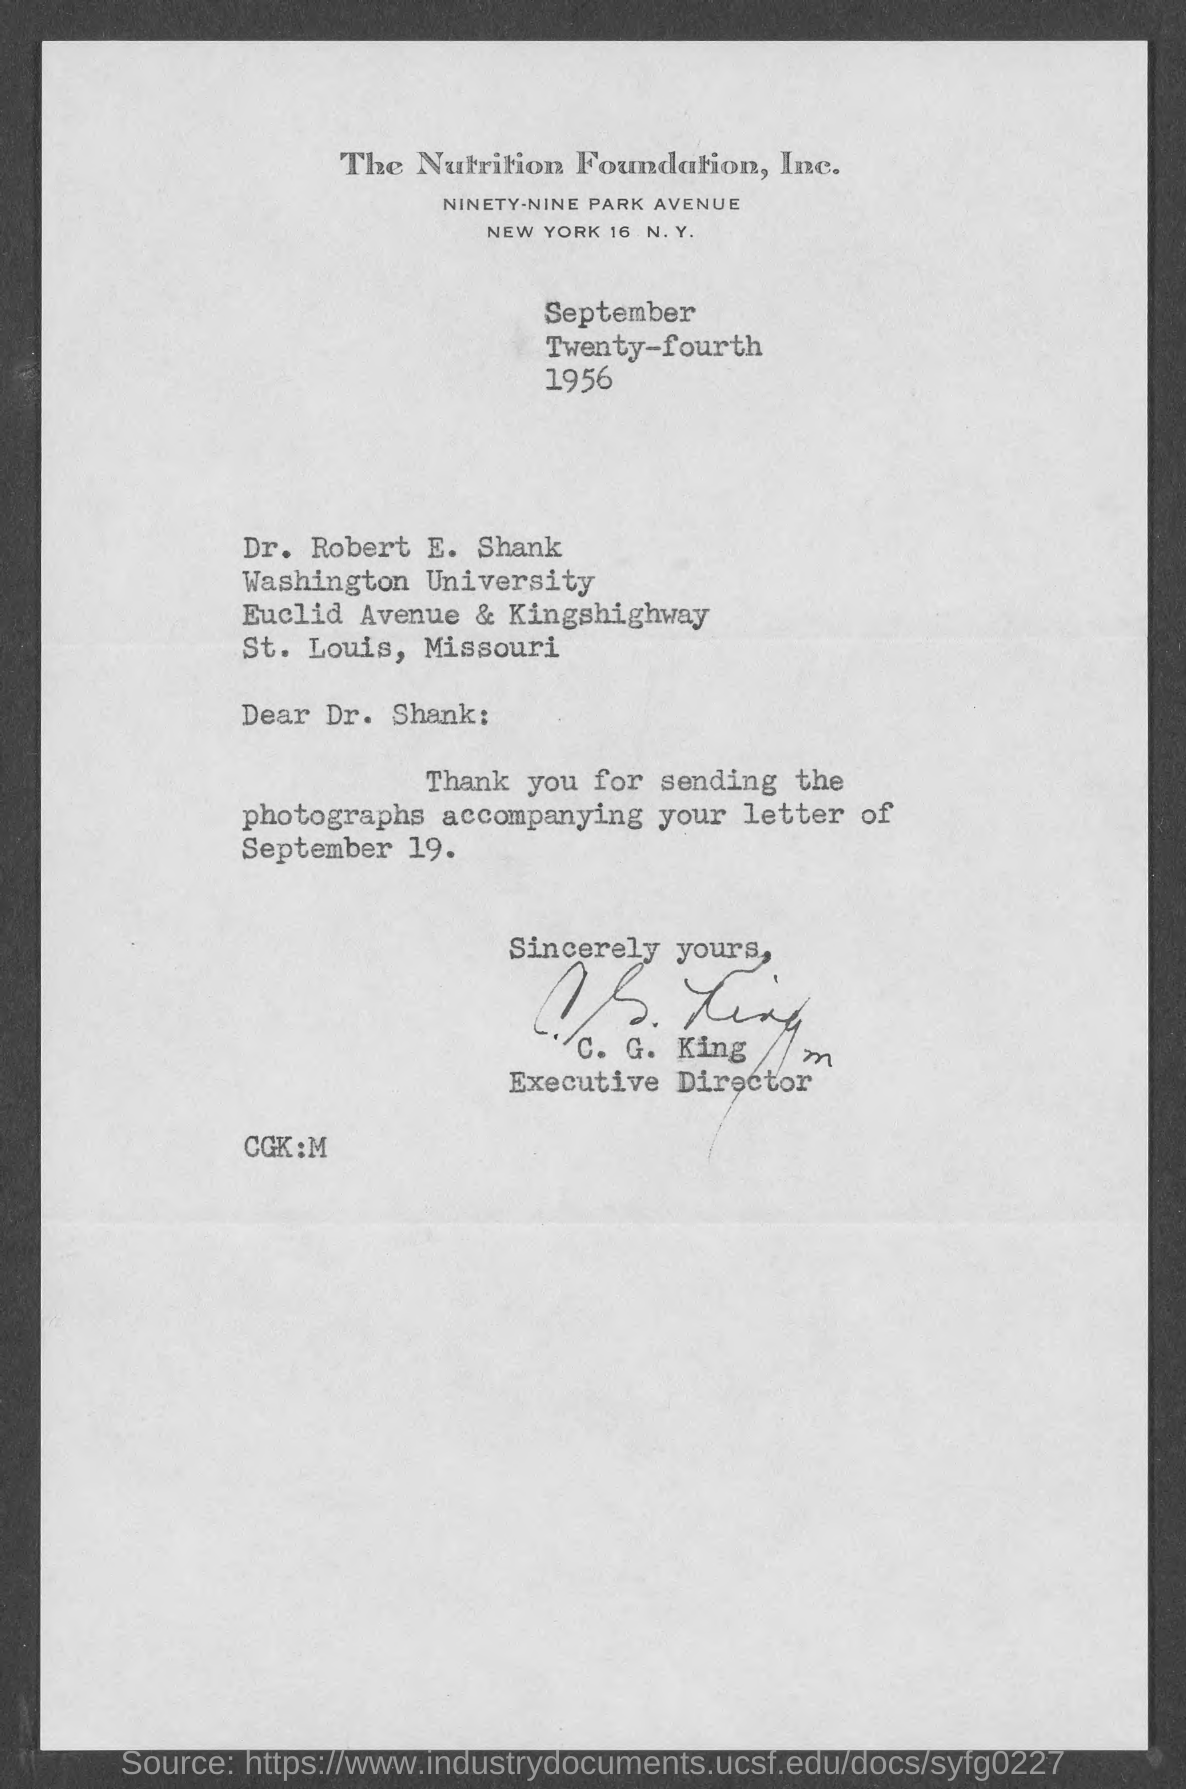Give some essential details in this illustration. The date on the document is September 24th, 1956. The letter is addressed to Dr. Robert E. Shank. The letter of September 19 is accompanied by photographs. 